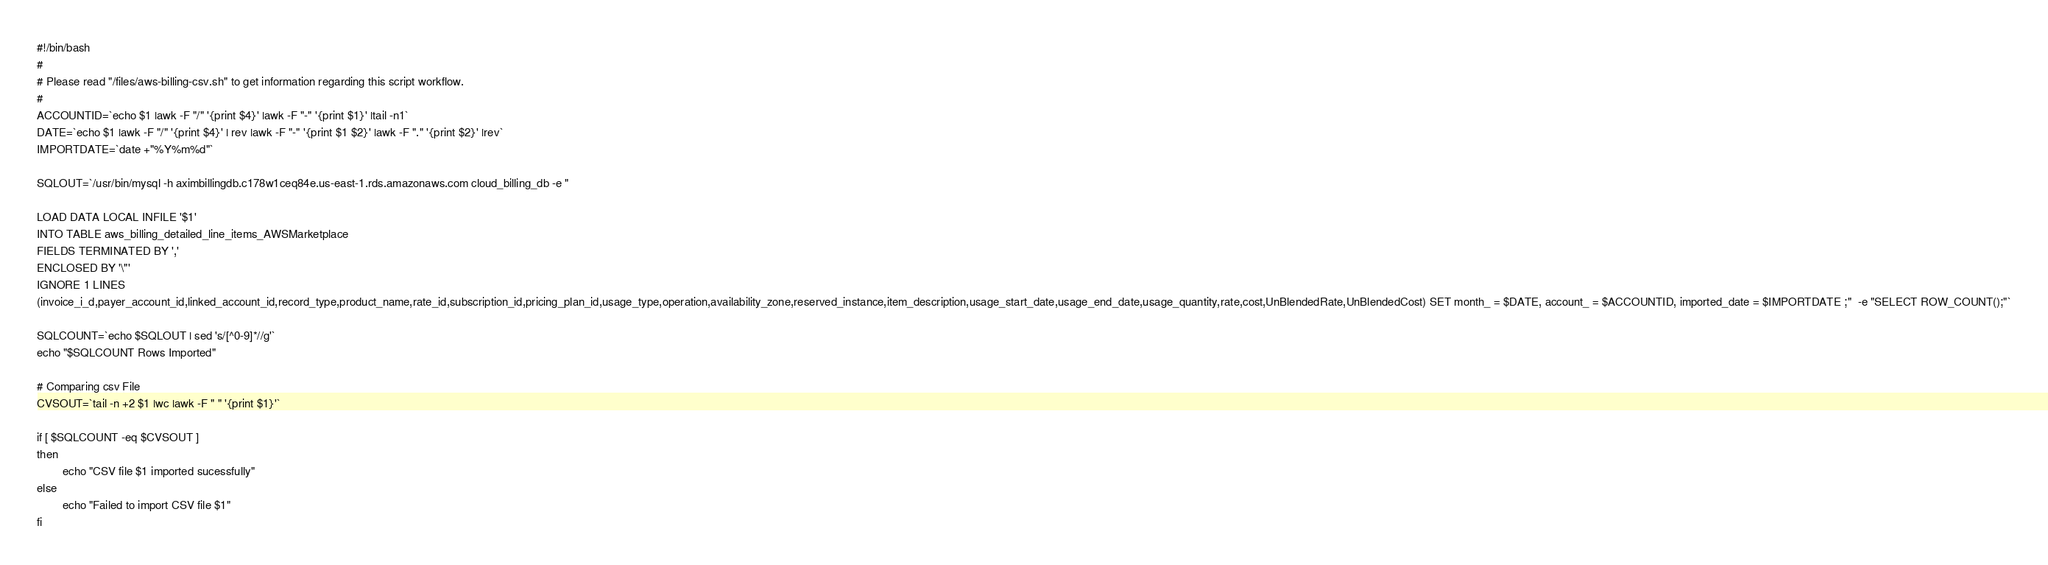<code> <loc_0><loc_0><loc_500><loc_500><_Bash_>#!/bin/bash
#
# Please read "/files/aws-billing-csv.sh" to get information regarding this script workflow.
#
ACCOUNTID=`echo $1 |awk -F "/" '{print $4}' |awk -F "-" '{print $1}' |tail -n1`
DATE=`echo $1 |awk -F "/" '{print $4}' | rev |awk -F "-" '{print $1 $2}' |awk -F "." '{print $2}' |rev`
IMPORTDATE=`date +"%Y%m%d"`

SQLOUT=`/usr/bin/mysql -h aximbillingdb.c178w1ceq84e.us-east-1.rds.amazonaws.com cloud_billing_db -e "

LOAD DATA LOCAL INFILE '$1'
INTO TABLE aws_billing_detailed_line_items_AWSMarketplace 
FIELDS TERMINATED BY ','
ENCLOSED BY '\"'
IGNORE 1 LINES
(invoice_i_d,payer_account_id,linked_account_id,record_type,product_name,rate_id,subscription_id,pricing_plan_id,usage_type,operation,availability_zone,reserved_instance,item_description,usage_start_date,usage_end_date,usage_quantity,rate,cost,UnBlendedRate,UnBlendedCost) SET month_ = $DATE, account_ = $ACCOUNTID, imported_date = $IMPORTDATE ;"  -e "SELECT ROW_COUNT();"`

SQLCOUNT=`echo $SQLOUT | sed 's/[^0-9]*//g'`
echo "$SQLCOUNT Rows Imported"

# Comparing csv File
CVSOUT=`tail -n +2 $1 |wc |awk -F " " '{print $1}'`

if [ $SQLCOUNT -eq $CVSOUT ]
then
        echo "CSV file $1 imported sucessfully"
else
        echo "Failed to import CSV file $1"
fi
</code> 